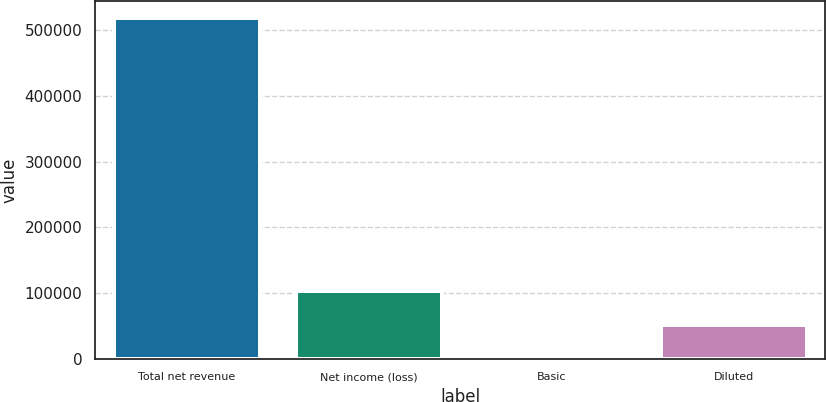Convert chart to OTSL. <chart><loc_0><loc_0><loc_500><loc_500><bar_chart><fcel>Total net revenue<fcel>Net income (loss)<fcel>Basic<fcel>Diluted<nl><fcel>517949<fcel>103590<fcel>0.11<fcel>51795<nl></chart> 